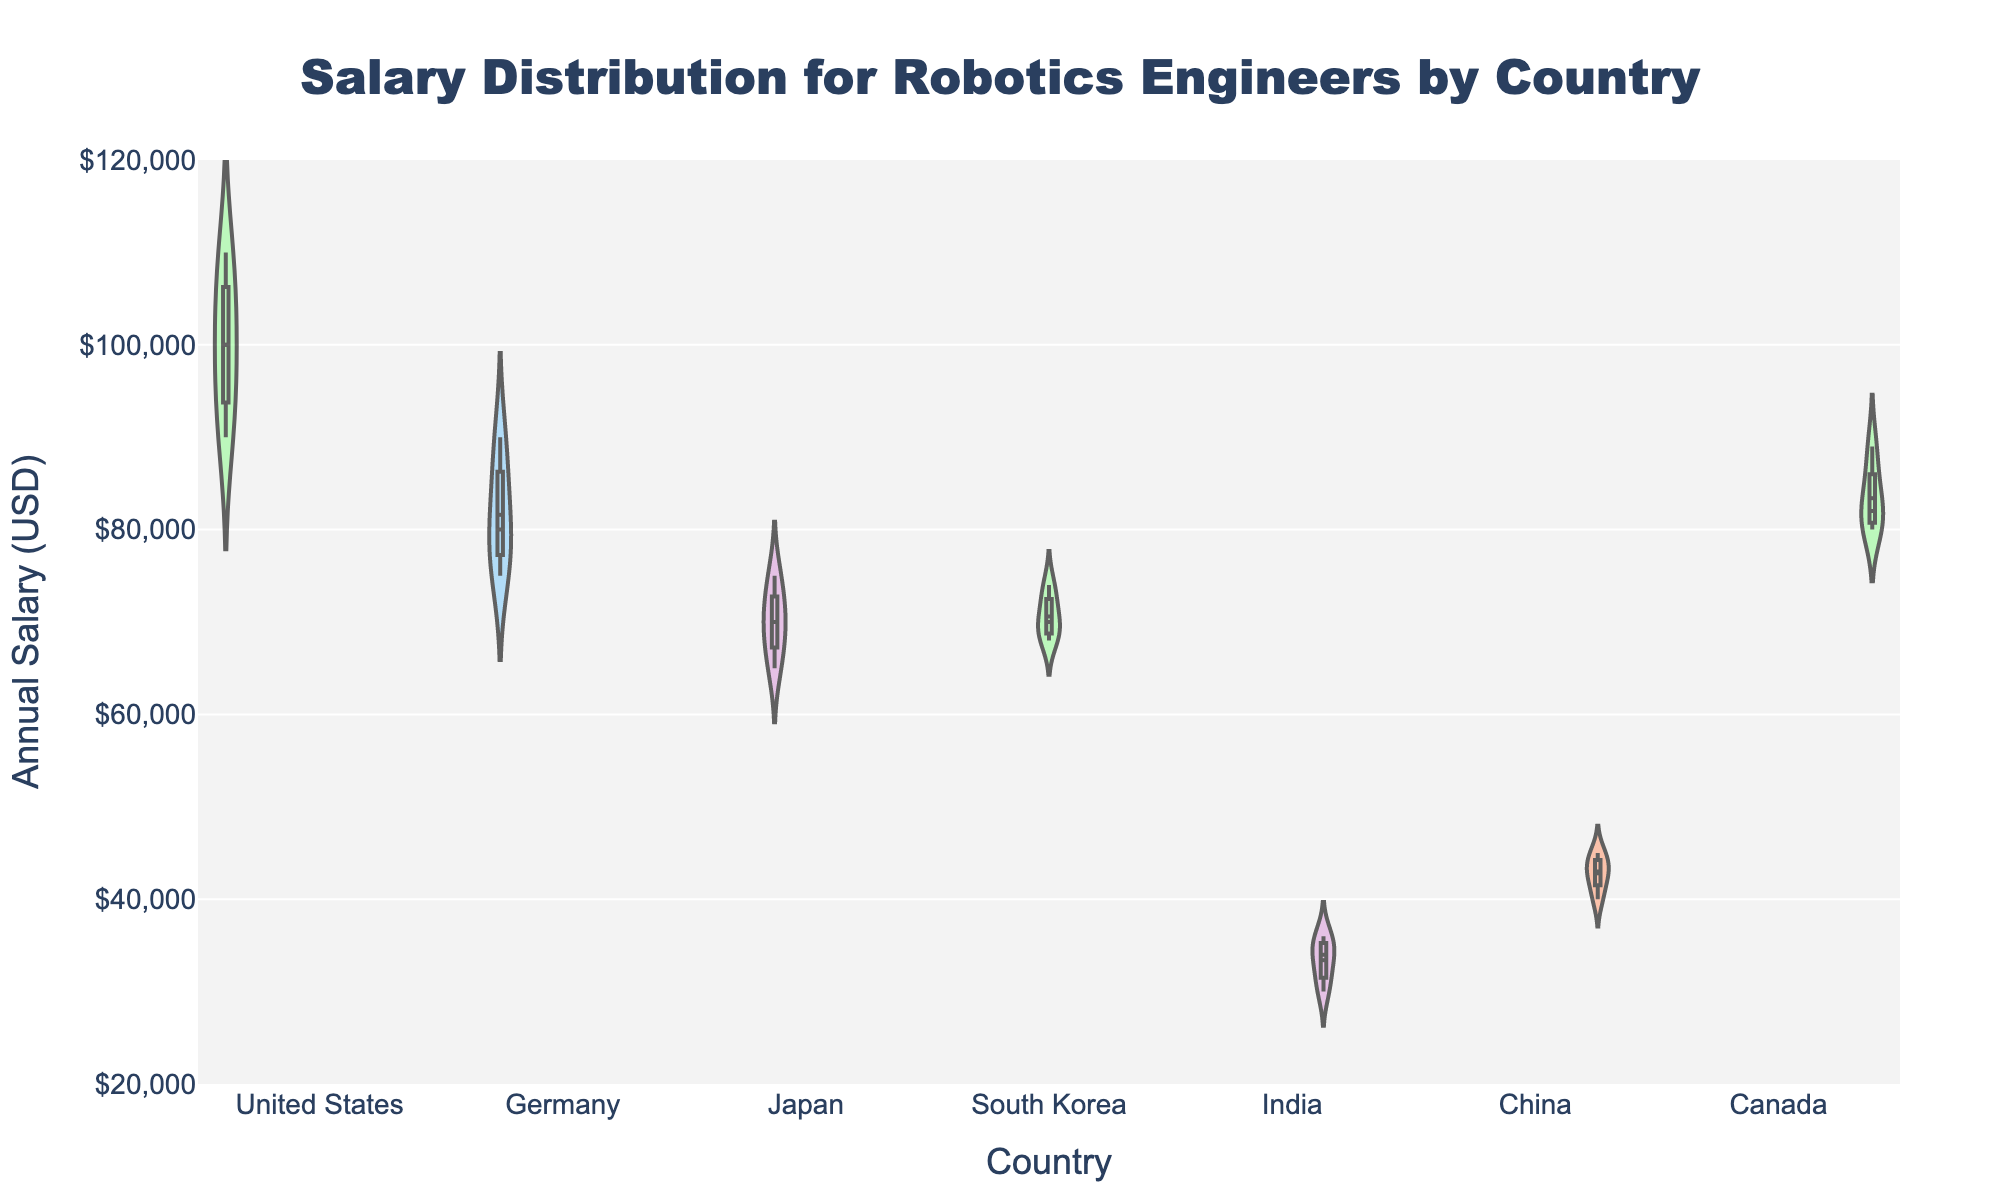what is the median salary for robotics engineers in the United States from the data visualized in the plot? The median salary is the middle value when the salaries are ordered. For the United States, the ordered salaries are: [90000, 95000, 100000, 105000, 110000]. The median is the middle number, 100000.
Answer: 100000 which country has the widest range of salary distribution for robotics engineers? The range of salary distribution can be assessed visually by checking the extent of the violin plot vertically. The United States appears to have the widest range, extending from around 90000 to 110000.
Answer: United States how does the salary distribution in Japan compare to India for robotics engineers? The violin plot shows Japan's salaries mostly between 65000 and 75000, whereas India's salaries range from 30000 to 36000. Japan has a higher salary range compared to India.
Answer: Japan has higher salaries what is the mean salary for robotics engineers in Germany according to the plot? The mean salary is indicated by the white dot in the violin plot for Germany. Visually, it appears to be around the middle of the distribution in the 78000 - 85000 range.
Answer: Approximately 81000 how does the average salary for robotics engineers in Canada compare to that in China? Visually compare the mean points (white dots) on the violin plots for both countries. Canada's mean appears around 85000, and China's appears around 42000. Thus, the average salary in Canada is notably higher.
Answer: Canada has a higher average salary which country's violin plot shows a median that is higher than 70000 but lower than 80000? The median is marked by the line in the center of the violin plot. Germany, South Korea, and Canada all fit this description based on visual inspection of the median line position.
Answer: Germany, South Korea, Canada what is the interquartile range (IQR) of salaries for robotics engineers in South Korea? The IQR is the range between the first quartile (25th percentile) and the third quartile (75th percentile). Visually, South Korea's first quartile is around 69000, and the third quartile is around 73000. The IQR is 73000 - 69000 = 4000.
Answer: 4000 which country has the least variance in salary distribution for robotics engineers? The variance can be visually assessed by the width of the violin plot. India has the narrowest width, indicating the least variance.
Answer: India 